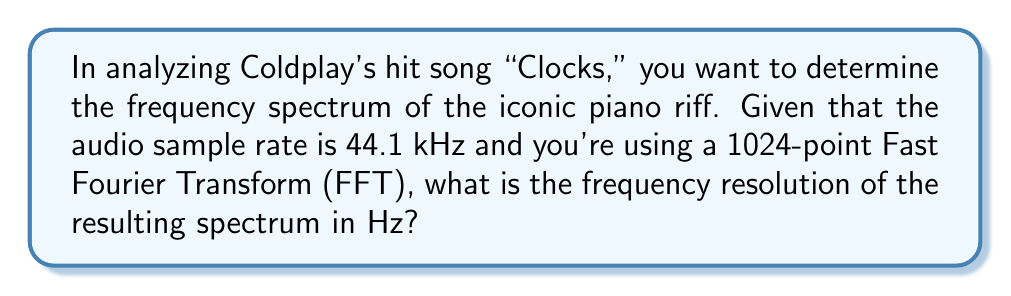Provide a solution to this math problem. To solve this problem, we need to understand the relationship between the FFT size, sample rate, and frequency resolution. The frequency resolution is the spacing between frequency bins in the resulting spectrum.

The formula for frequency resolution is:

$$\text{Frequency Resolution} = \frac{\text{Sample Rate}}{\text{FFT Size}}$$

Given:
- Sample rate = 44.1 kHz = 44,100 Hz
- FFT size = 1024 points

Let's substitute these values into the formula:

$$\text{Frequency Resolution} = \frac{44,100 \text{ Hz}}{1024}$$

Now, let's perform the division:

$$\text{Frequency Resolution} = 43.06640625 \text{ Hz}$$

This means that each frequency bin in the resulting spectrum represents a range of approximately 43.07 Hz.

Understanding this concept is crucial for music producers, as it affects the precision with which you can analyze different frequency components in a song. A lower frequency resolution (higher value) means less precise frequency discrimination, while a higher resolution (lower value) allows for more detailed analysis of closely spaced frequency components.
Answer: 43.07 Hz (rounded to two decimal places) 